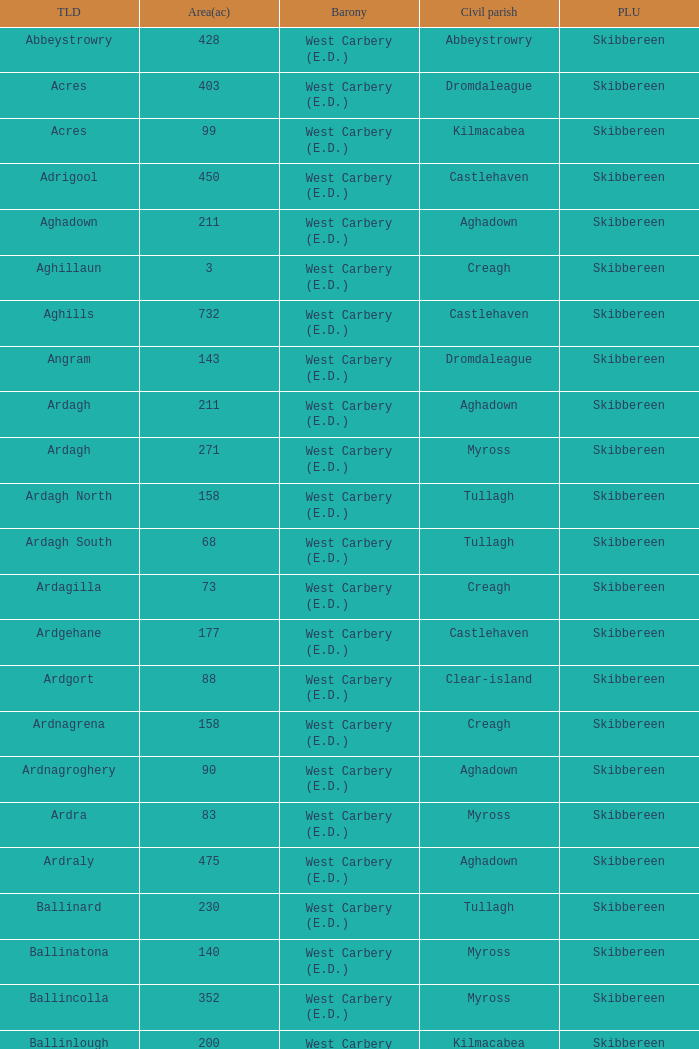What are the Baronies when the area (in acres) is 276? West Carbery (E.D.). 